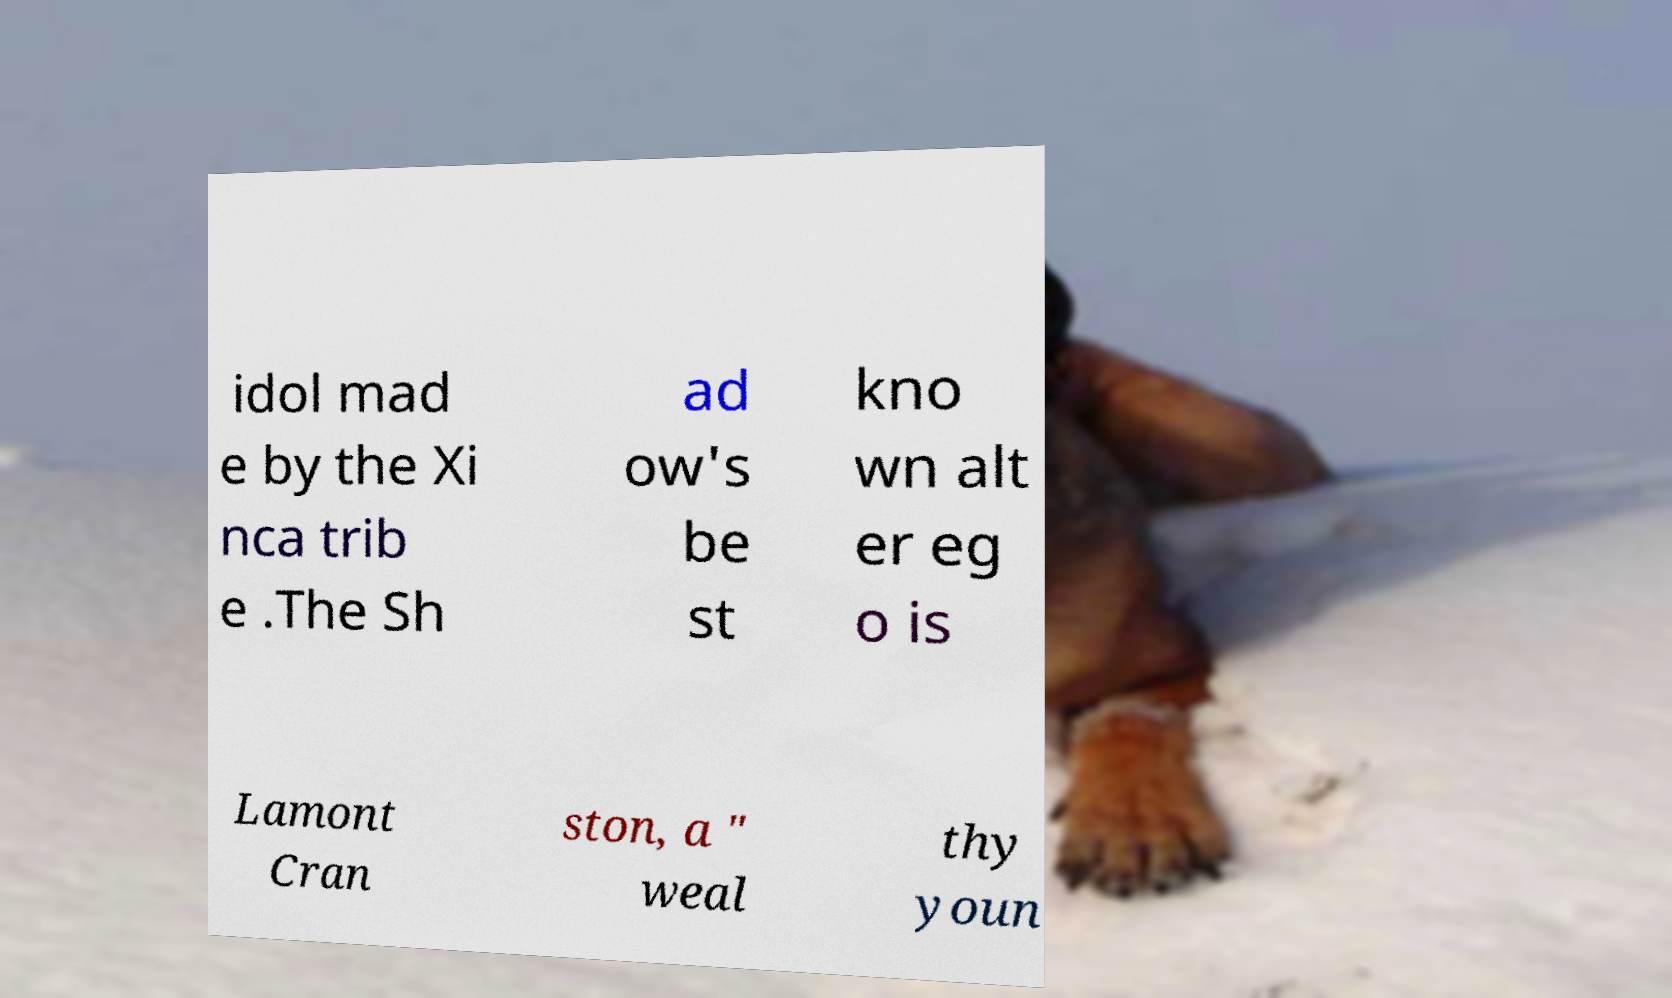Could you assist in decoding the text presented in this image and type it out clearly? idol mad e by the Xi nca trib e .The Sh ad ow's be st kno wn alt er eg o is Lamont Cran ston, a " weal thy youn 